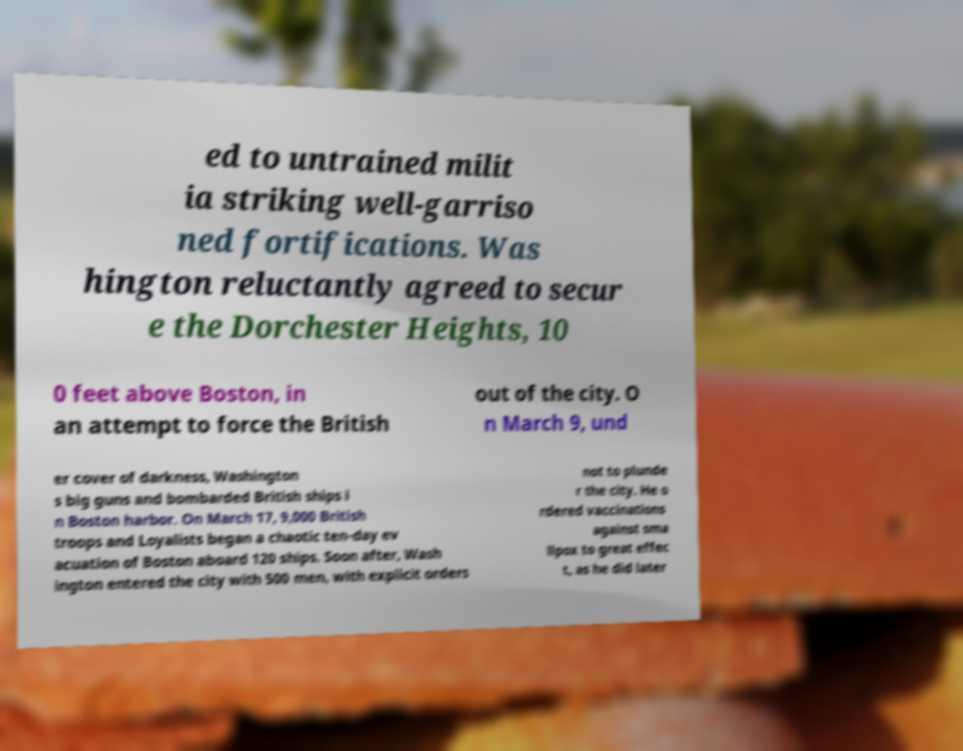What messages or text are displayed in this image? I need them in a readable, typed format. ed to untrained milit ia striking well-garriso ned fortifications. Was hington reluctantly agreed to secur e the Dorchester Heights, 10 0 feet above Boston, in an attempt to force the British out of the city. O n March 9, und er cover of darkness, Washington s big guns and bombarded British ships i n Boston harbor. On March 17, 9,000 British troops and Loyalists began a chaotic ten-day ev acuation of Boston aboard 120 ships. Soon after, Wash ington entered the city with 500 men, with explicit orders not to plunde r the city. He o rdered vaccinations against sma llpox to great effec t, as he did later 